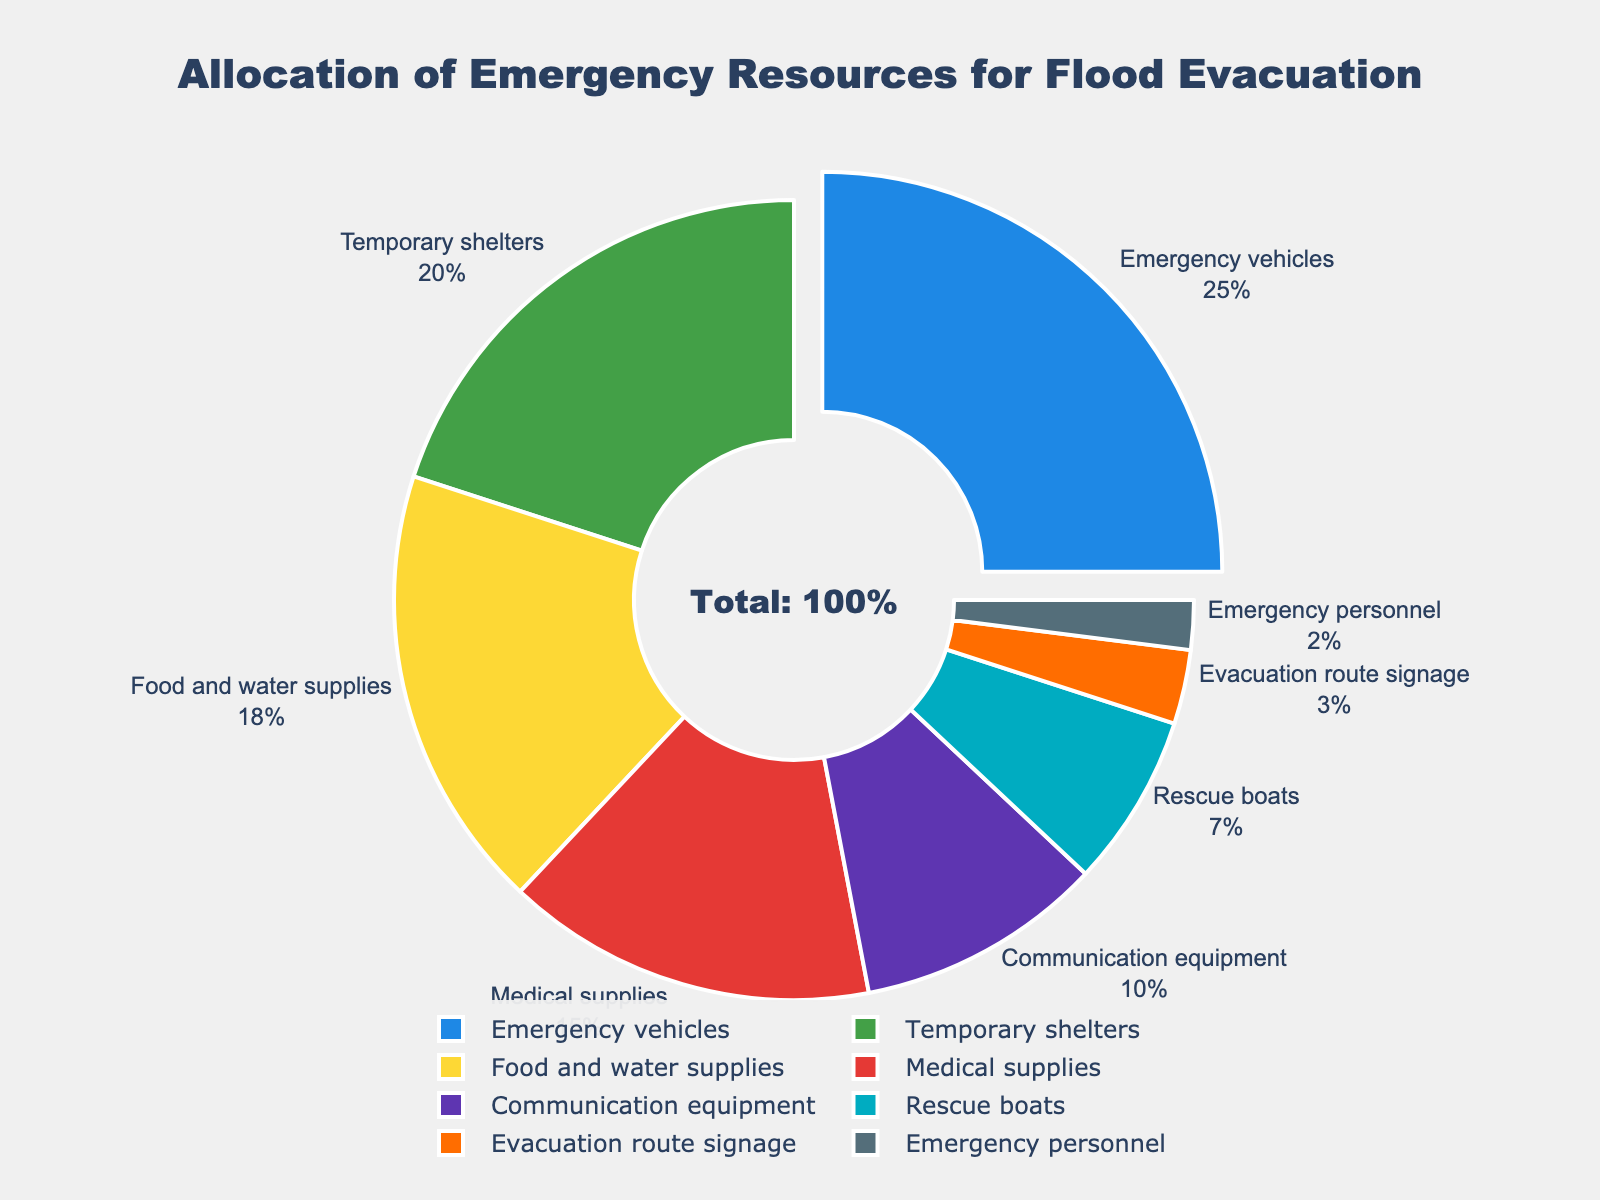Which category receives the highest allocation of emergency resources? The category with the largest percentage on the pie chart is the "Emergency vehicles" segment. It is slightly pulled out from the rest to highlight its dominance.
Answer: Emergency vehicles By how much does the allocation for emergency vehicles exceed the allocation for medical supplies? Emergency vehicles have a 25% allocation, and medical supplies have a 15% allocation. The difference is calculated as 25% - 15%.
Answer: 10% What is the combined percentage of resources allocated to food and water supplies, and temporary shelters? The percentage for food and water supplies is 18%, and for temporary shelters, it is 20%. Adding these gives 18% + 20%.
Answer: 38% Which category has the least allocated resources, and what is its percentage? The smallest segment on the pie chart is the "Emergency personnel". It is the smallest slice near the bottom.
Answer: Emergency personnel, 2% What percentage of resources is allocated to medical supplies, communication equipment, and rescue boats combined? Medical supplies have a 15% allocation, communication equipment has 10%, and rescue boats have 7%. Summing these gives 15% + 10% + 7%.
Answer: 32% Is the allocation for food and water supplies greater than the allocation for rescue boats? If yes, by how much? The allocation for food and water supplies is 18% and for rescue boats, it is 7%. The difference is calculated as 18% - 7%.
Answer: Yes, by 11% How much more percentage is allocated to temporary shelters compared to evacuation route signage? The allocation for temporary shelters is 20%, and for evacuation route signage, it is 3%. The difference is 20% - 3%.
Answer: 17% What fraction of the total percentage is allocated to communication equipment? The allocation for communication equipment is 10%. Since the total percentage represented by the pie chart is 100%, the fraction is 10/100.
Answer: 1/10 Which two categories together make up 60% of the allocation? Emergency vehicles have 25% and temporary shelters have 20%, together making 45%. Adding food and water supplies (18%), we exceed 60%. So, the correct categories are emergency vehicles (25%), temporary shelters (20%), and medical supplies (15%), but no two categories make up exactly 60%.
Answer: Emergency vehicles and temporary shelters make up 45%; more than two needed for exactly 60% Is the allocation for emergency vehicles equal to the combined allocation for medical supplies and communication equipment? Emergency vehicles have a 25% allocation. The sum of allocations for medical supplies (15%) and communication equipment (10%) is also 25%.
Answer: Yes 